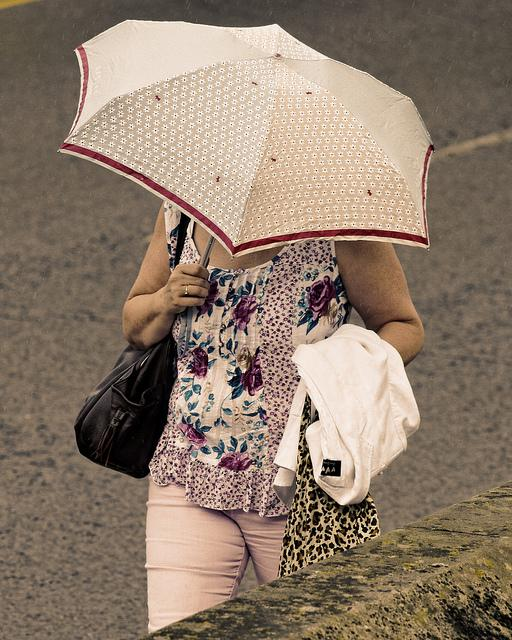Why is she holding an umbrella in dry weather? Please explain your reasoning. sun protection. Since it is dry, she is using the umbrella to provide shade. 